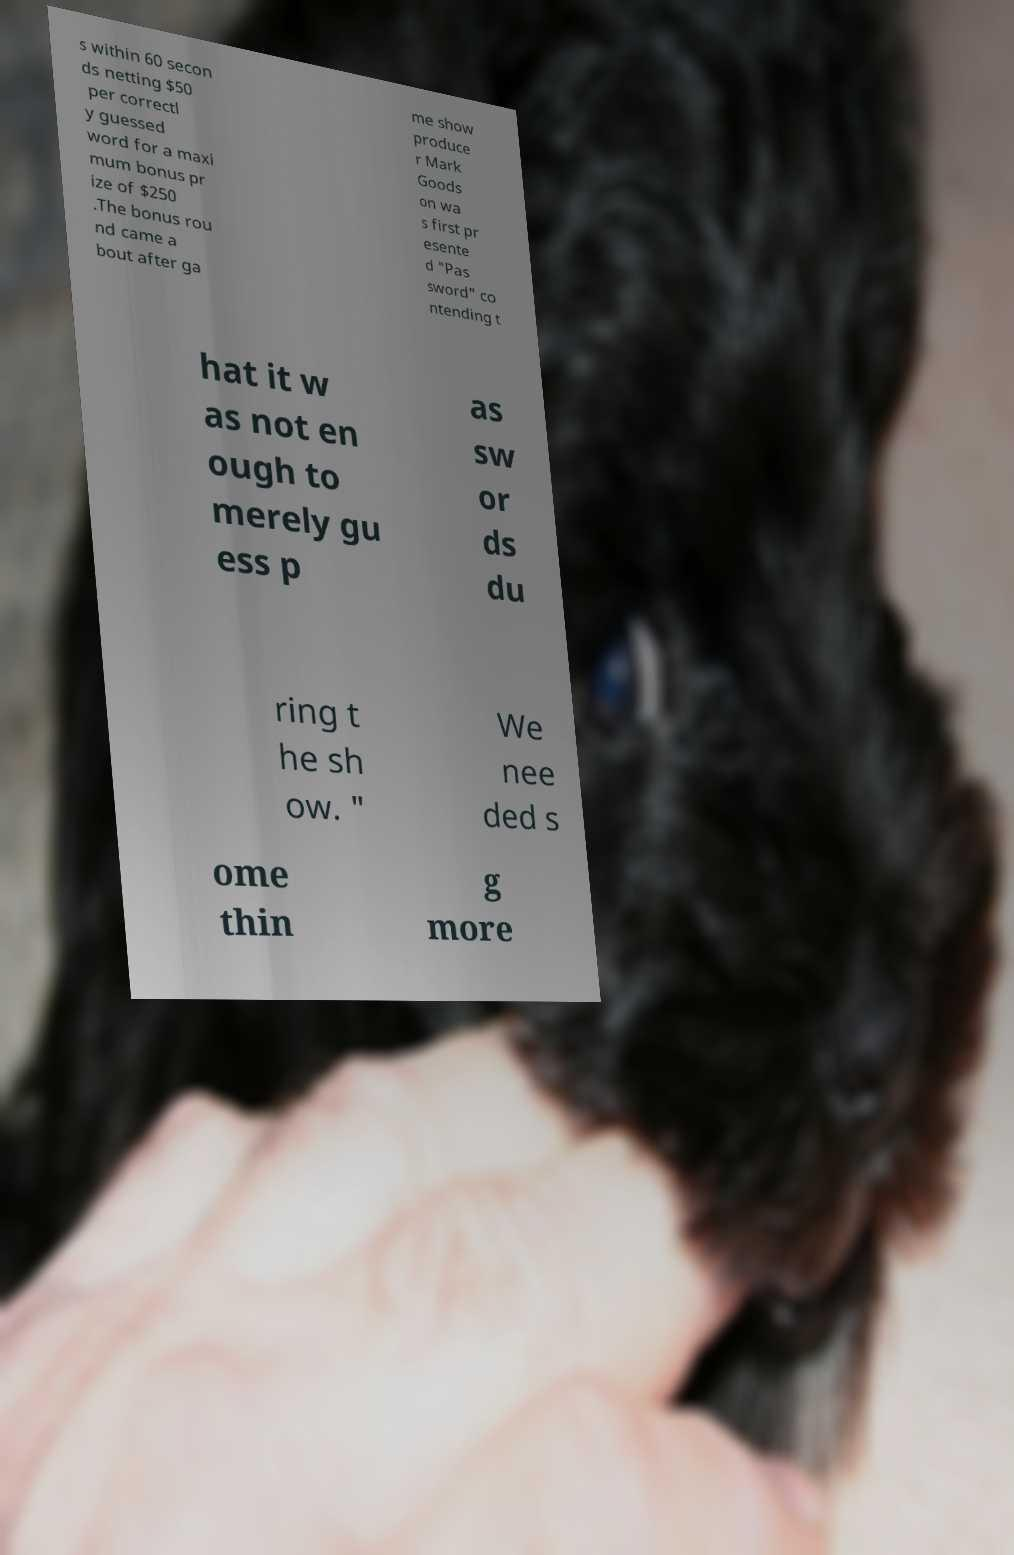Could you extract and type out the text from this image? s within 60 secon ds netting $50 per correctl y guessed word for a maxi mum bonus pr ize of $250 .The bonus rou nd came a bout after ga me show produce r Mark Goods on wa s first pr esente d "Pas sword" co ntending t hat it w as not en ough to merely gu ess p as sw or ds du ring t he sh ow. " We nee ded s ome thin g more 